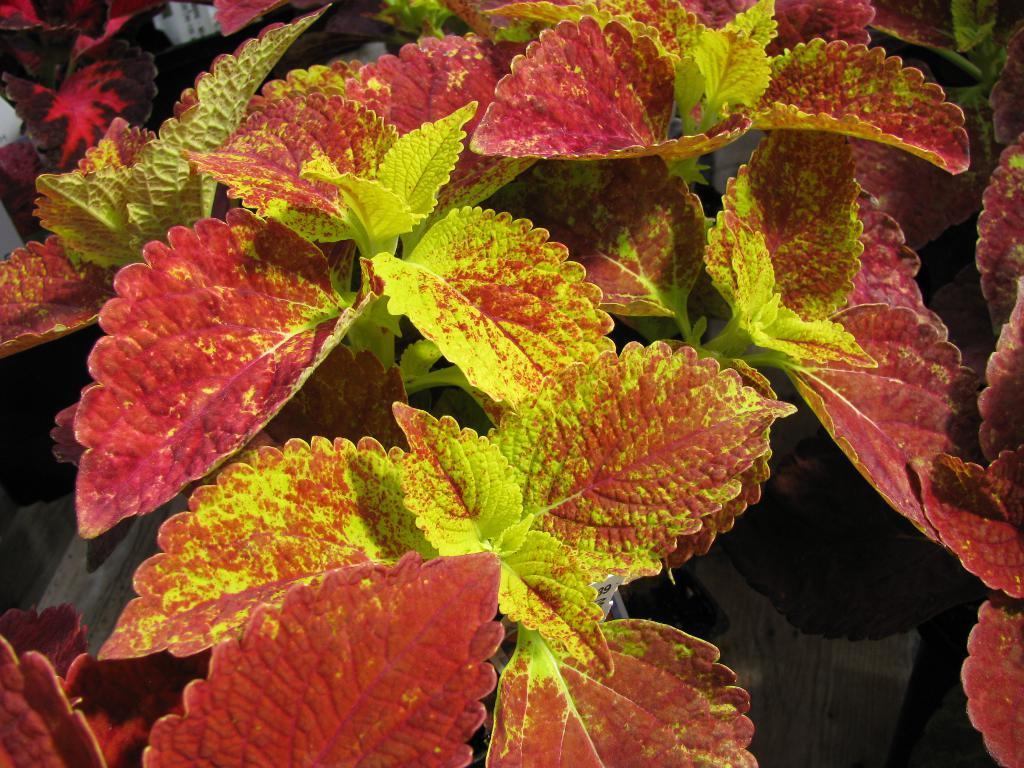Describe this image in one or two sentences. In this image I can see red and green color leaves. 